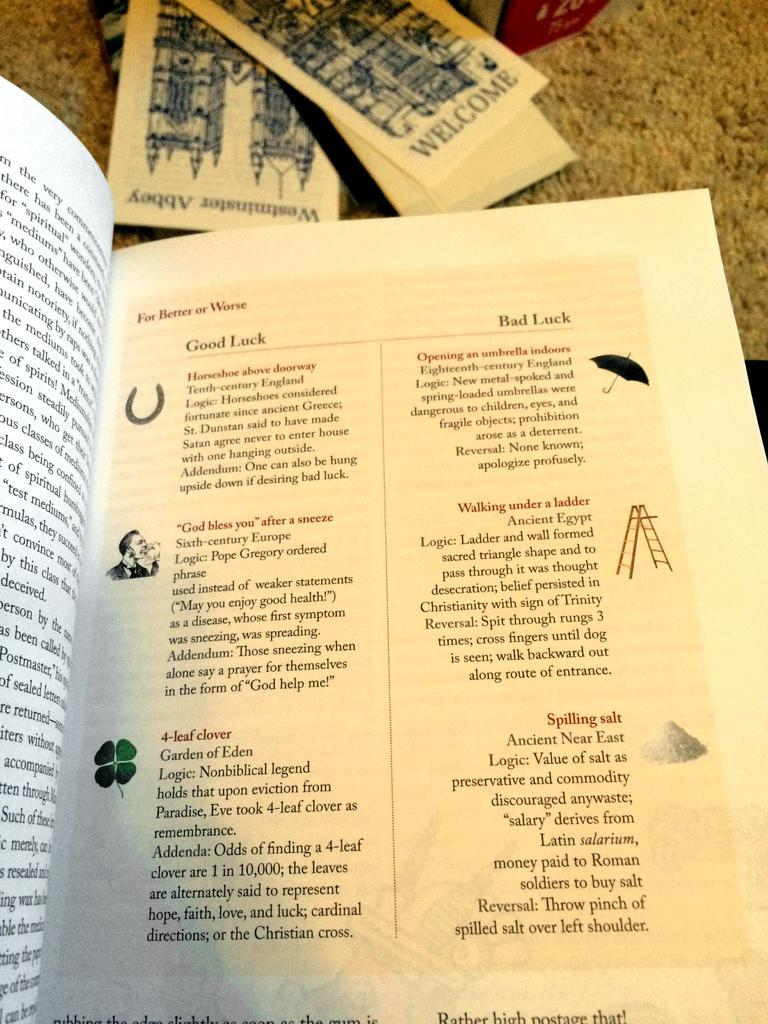Provide a one-sentence caption for the provided image. A book page describing good and bad luck. 